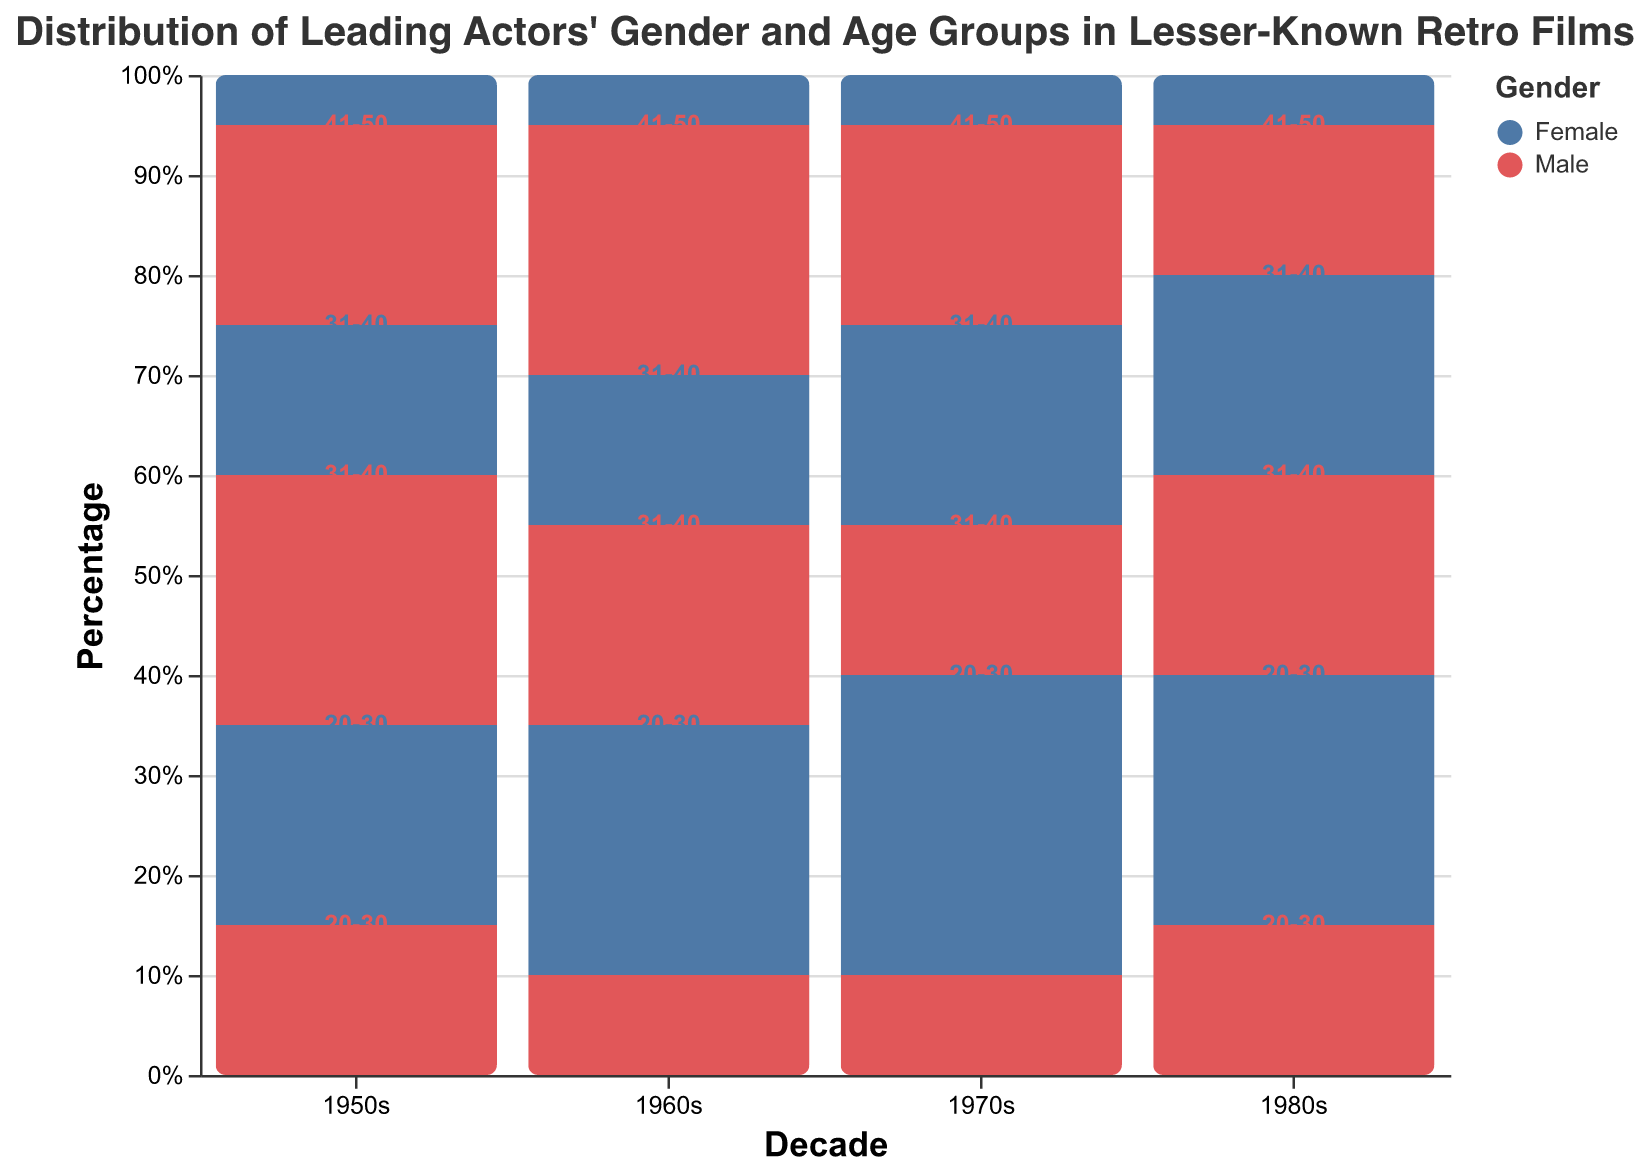What is the most common age group for male leading actors in the 1950s? In the 1950s, the percentages for male leading actors are 15% for 20-30, 25% for 31-40, and 20% for 41-50. The highest percentage is 25% for the 31-40 age group.
Answer: 31-40 Which decade features the highest percentage of female leading actors aged 20-30? The percentages for female leading actors aged 20-30 are 20% in the 1950s, 25% in the 1960s, 30% in the 1970s, and 25% in the 1980s. The highest percentage is 30% in the 1970s.
Answer: 1970s What is the total percentage of male leading actors in the 1970s? The percentages for male leading actors in the 1970s are 10% for 20-30, 15% for 31-40, and 20% for 41-50. Summing these up gives 10 + 15 + 20 = 45%.
Answer: 45% How does the distribution of leading actors' gender in the 1980s compare to the 1950s? In the 1980s, the percentage of male leading actors is 15% (20-30), 20% (31-40), 15% (41-50) totaling 50%. For females, it's 25% (20-30), 20% (31-40), 5% (41-50) totaling 50%. In the 1950s, males are 15%, 25%, 20% totaling 60%; females are 20%, 15%, 5% totaling 40%. So, both genders are more balanced in the 1980s compared to the higher male dominance in the 1950s.
Answer: More balanced gender distribution in the 1980s What is the percentage difference between male and female leading actors aged 41-50 in the 1960s? For the 1960s, the percentage for male leading actors aged 41-50 is 25%, and for females, it's 5%. The difference is 25% - 5% = 20%.
Answer: 20% In which decade did female leading actors aged 31-40 hold equal percentages? In the 1960s and 1980s, female leading actors aged 31-40 each have a percentage of 15% and 20% respectively. The equal percentage is not present in any other decades.
Answer: Not equal in any decade What is the trend of female leading actors aged 41-50 across the decades? The percentages for female leading actors aged 41-50 are 5% in the 1950s, 5% in the 1960s, 5% in the 1970s, and 5% in the 1980s. This shows a consistent trend of 5% across all decades.
Answer: Consistent at 5% Which gender had a higher percentage of leading actors aged 20-30 in the 1970s? In the 1970s, the percentage for male leading actors aged 20-30 is 10%, and for females, it is 30%. Females had a higher percentage.
Answer: Female What was the percentage of female leading actors of 31-40, in the decade that had the highest percentage for this group? The highest percentage for female leading actors aged 31-40 is in the 1970s, which is 20%.
Answer: 20% What is the difference between the highest and the lowest percentage for any age group for females across all decades? The highest percentage for any female age group is 30% (20-30, 1970s), and the lowest is 5% (41-50, multiple decades). The difference is 30% - 5% = 25%.
Answer: 25% 